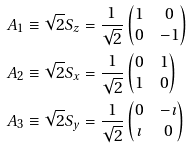<formula> <loc_0><loc_0><loc_500><loc_500>A _ { 1 } & \equiv \sqrt { 2 } S _ { z } = \frac { 1 } { \sqrt { 2 } } \begin{pmatrix} 1 & 0 \\ 0 & - 1 \end{pmatrix} \\ A _ { 2 } & \equiv \sqrt { 2 } S _ { x } = \frac { 1 } { \sqrt { 2 } } \begin{pmatrix} 0 & 1 \\ 1 & 0 \end{pmatrix} \\ A _ { 3 } & \equiv \sqrt { 2 } S _ { y } = \frac { 1 } { \sqrt { 2 } } \begin{pmatrix} 0 & - \imath \\ \imath & 0 \end{pmatrix}</formula> 